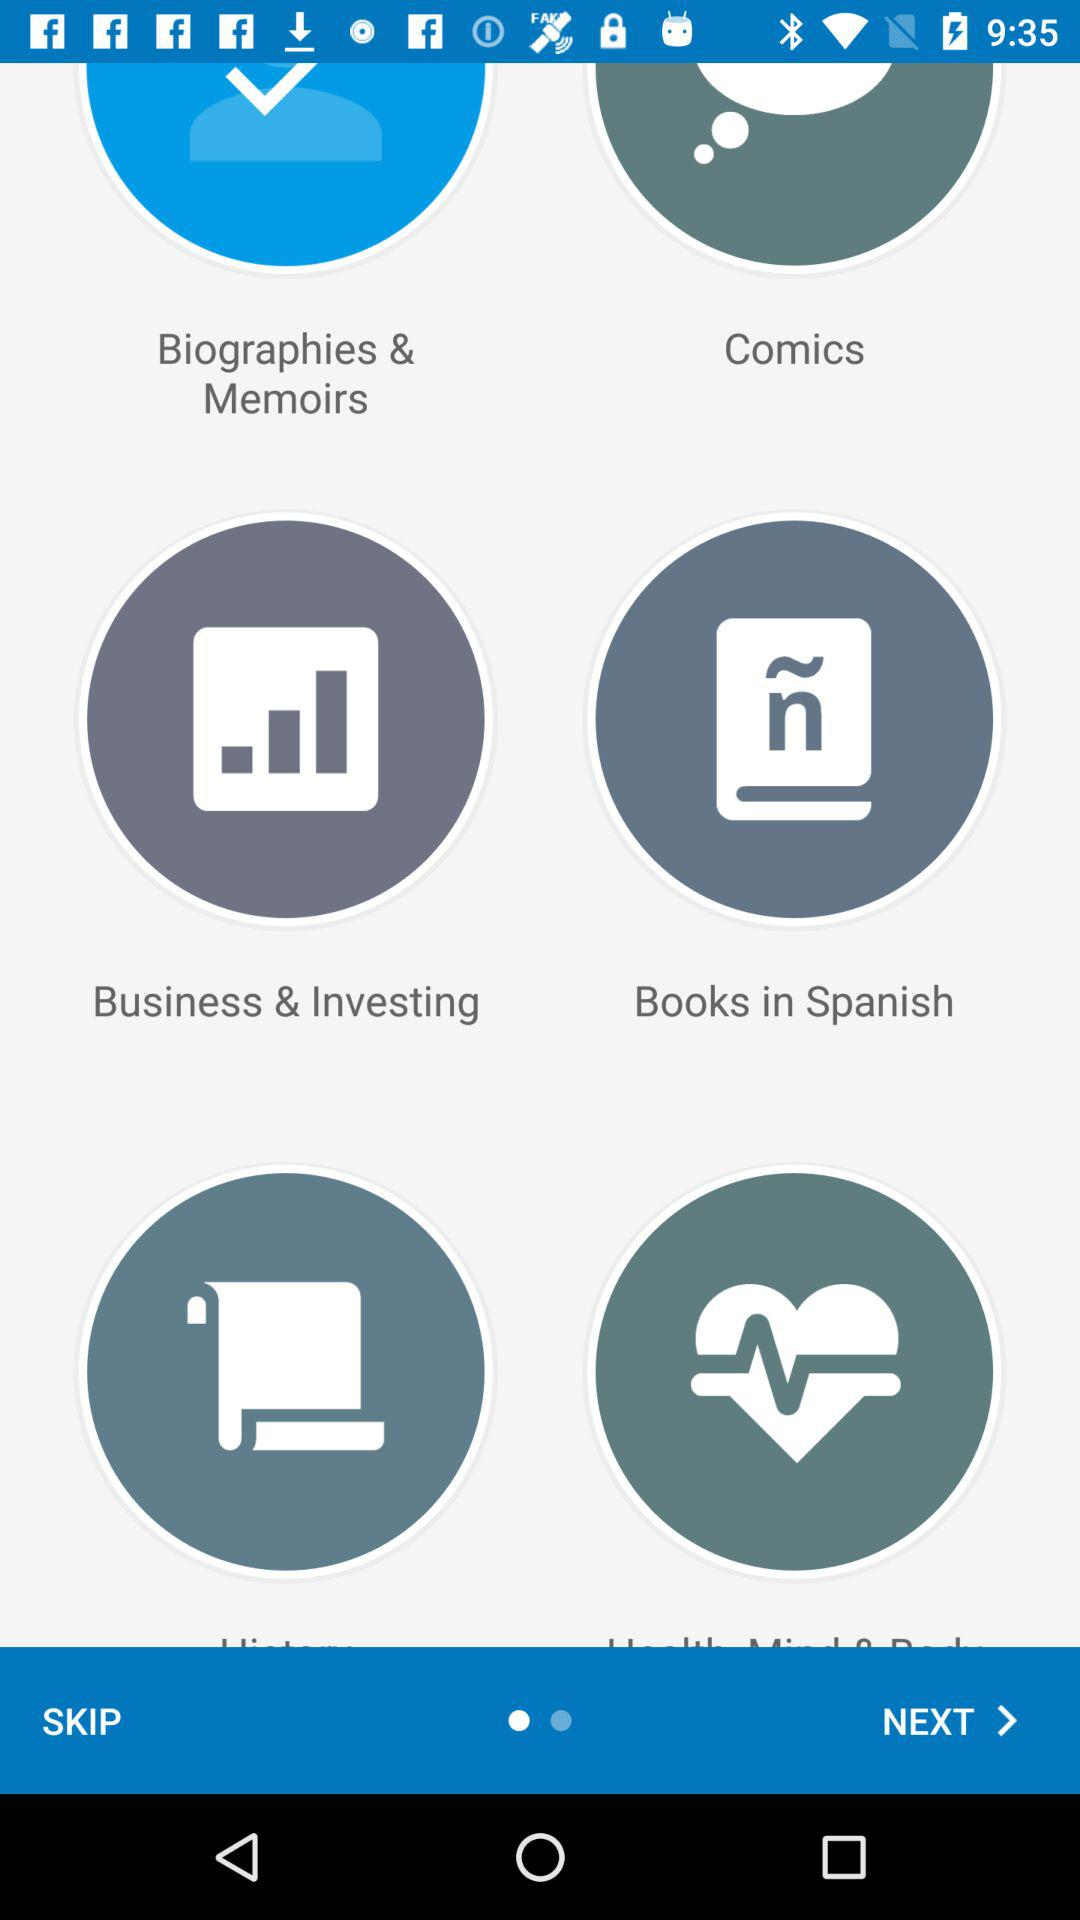What are the available options? The available options are "Biographies & Memoirs", "Comics", "Business & Investing" and "Books in Spanish". 